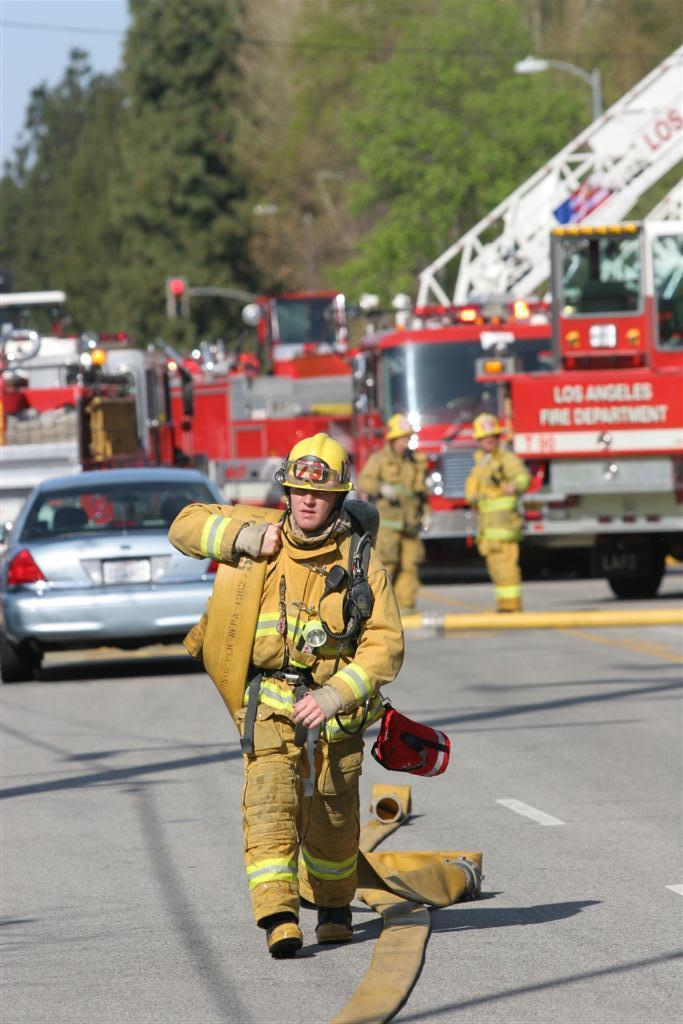<image>
Provide a brief description of the given image. a Los Angeles fire tuck that is on the street 